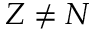<formula> <loc_0><loc_0><loc_500><loc_500>Z \neq N</formula> 